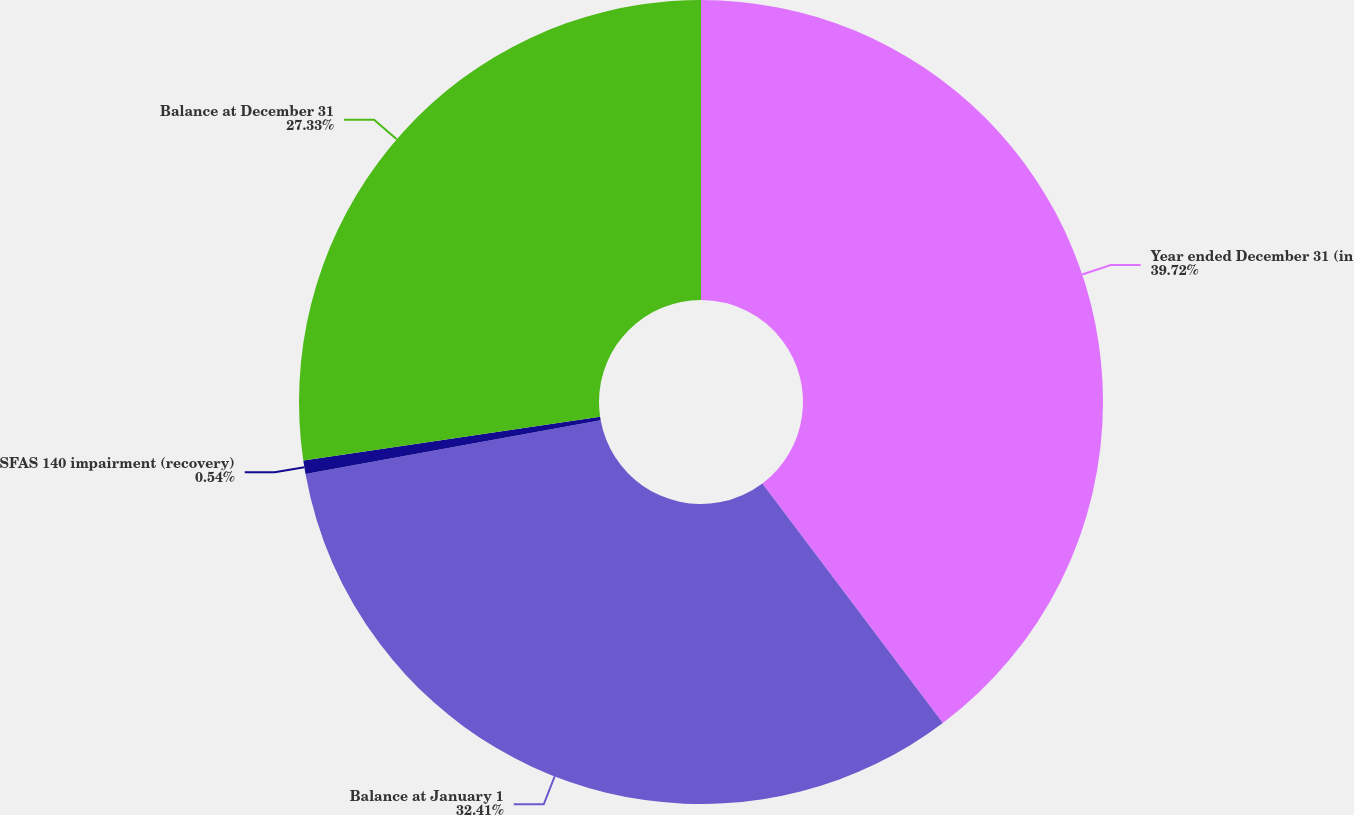Convert chart. <chart><loc_0><loc_0><loc_500><loc_500><pie_chart><fcel>Year ended December 31 (in<fcel>Balance at January 1<fcel>SFAS 140 impairment (recovery)<fcel>Balance at December 31<nl><fcel>39.73%<fcel>32.41%<fcel>0.54%<fcel>27.33%<nl></chart> 